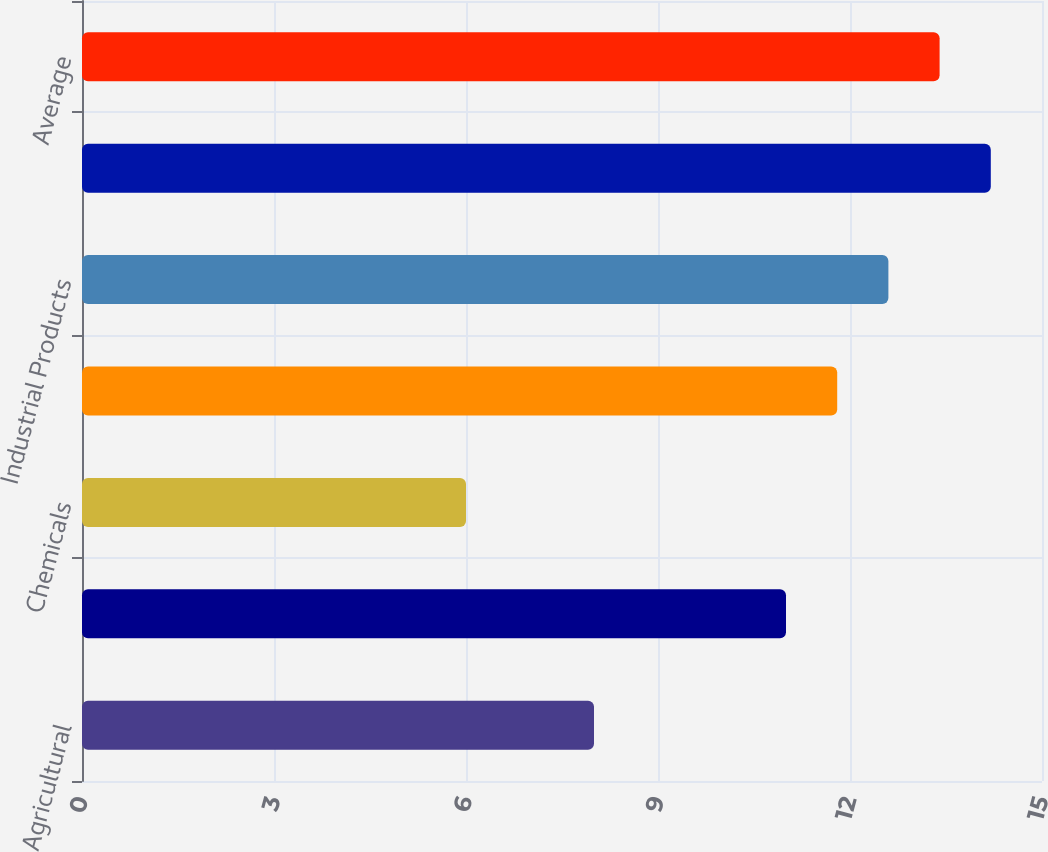Convert chart to OTSL. <chart><loc_0><loc_0><loc_500><loc_500><bar_chart><fcel>Agricultural<fcel>Automotive<fcel>Chemicals<fcel>Energy<fcel>Industrial Products<fcel>Intermodal a<fcel>Average<nl><fcel>8<fcel>11<fcel>6<fcel>11.8<fcel>12.6<fcel>14.2<fcel>13.4<nl></chart> 